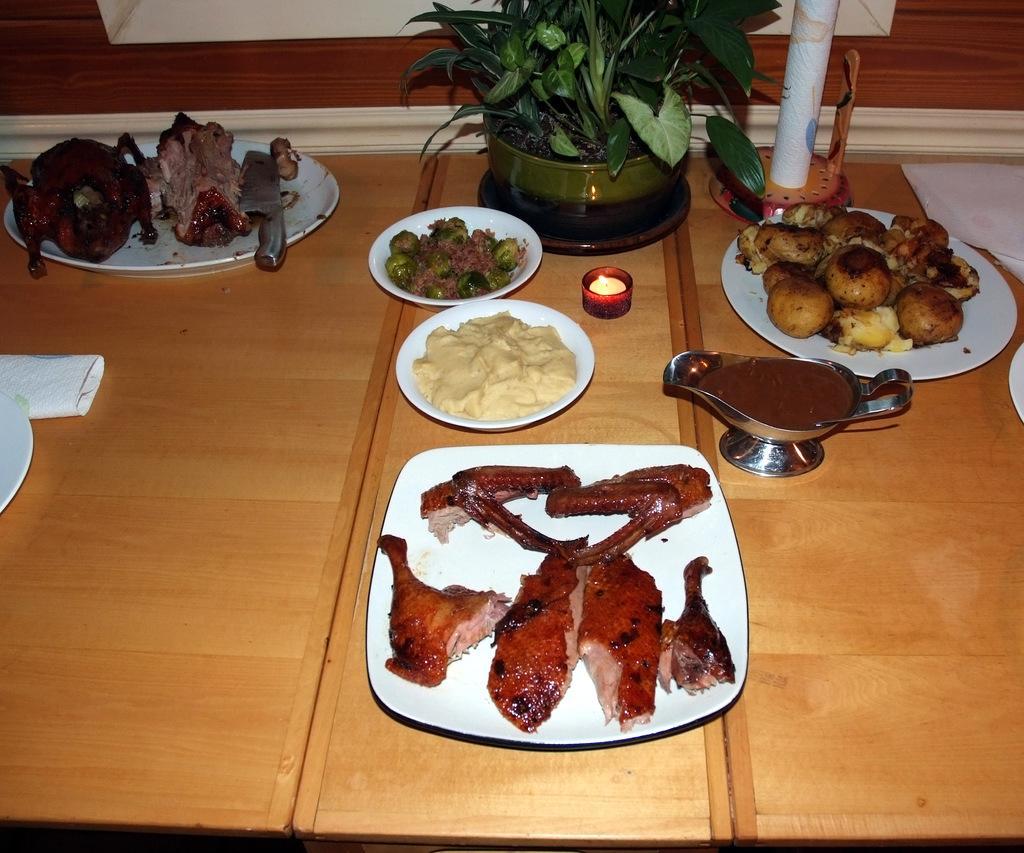How would you summarize this image in a sentence or two? In this image I can see the brown color table. On the table I can see the plates with food and the flower pot. The plates are in white color and the food is colorful. To the side I can see one more white color box. 